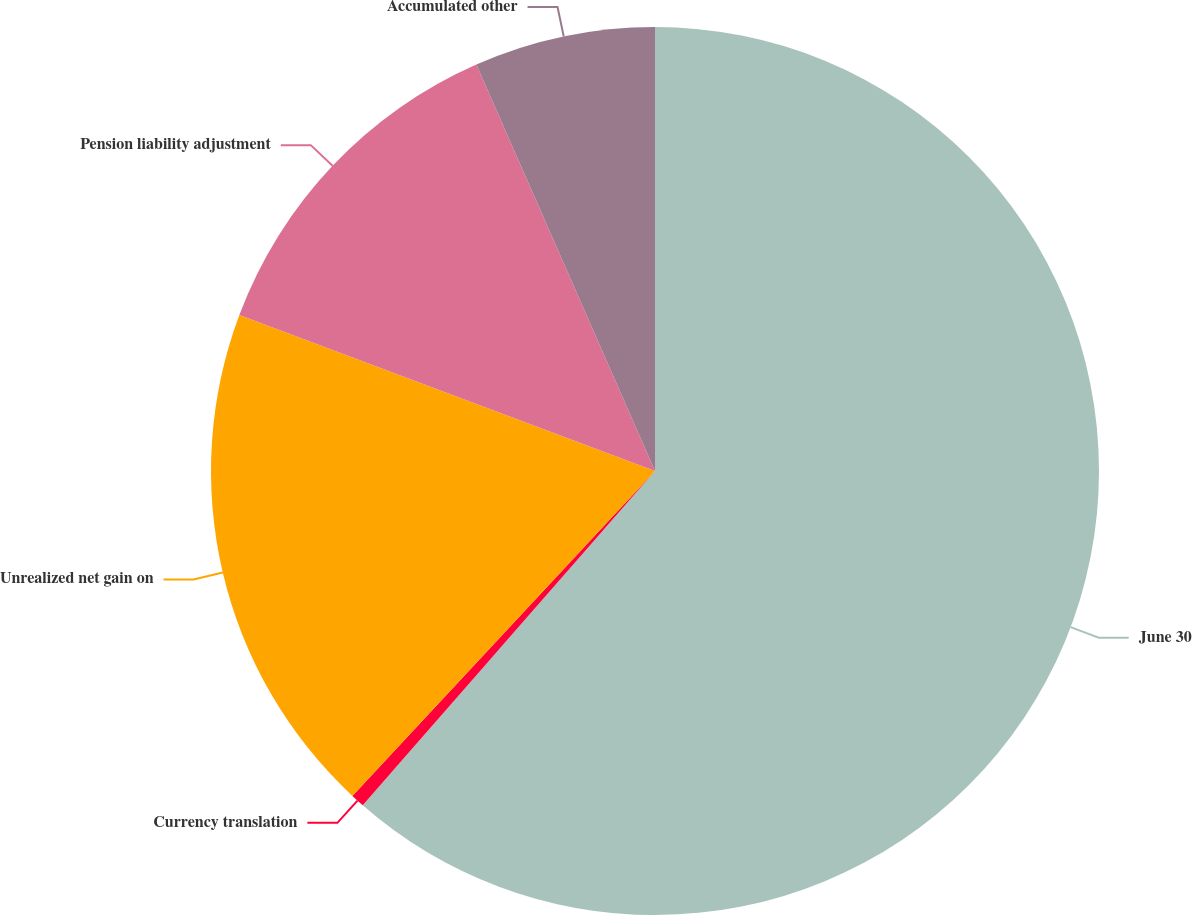Convert chart to OTSL. <chart><loc_0><loc_0><loc_500><loc_500><pie_chart><fcel>June 30<fcel>Currency translation<fcel>Unrealized net gain on<fcel>Pension liability adjustment<fcel>Accumulated other<nl><fcel>61.43%<fcel>0.5%<fcel>18.78%<fcel>12.69%<fcel>6.59%<nl></chart> 